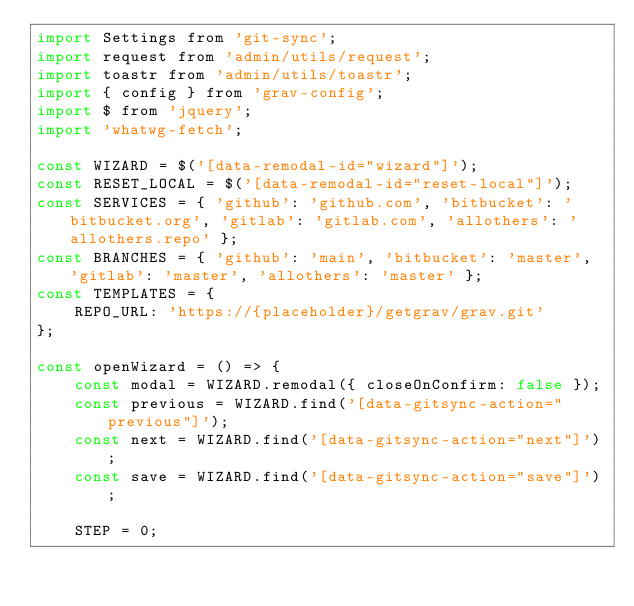Convert code to text. <code><loc_0><loc_0><loc_500><loc_500><_JavaScript_>import Settings from 'git-sync';
import request from 'admin/utils/request';
import toastr from 'admin/utils/toastr';
import { config } from 'grav-config';
import $ from 'jquery';
import 'whatwg-fetch';

const WIZARD = $('[data-remodal-id="wizard"]');
const RESET_LOCAL = $('[data-remodal-id="reset-local"]');
const SERVICES = { 'github': 'github.com', 'bitbucket': 'bitbucket.org', 'gitlab': 'gitlab.com', 'allothers': 'allothers.repo' };
const BRANCHES = { 'github': 'main', 'bitbucket': 'master', 'gitlab': 'master', 'allothers': 'master' };
const TEMPLATES = {
    REPO_URL: 'https://{placeholder}/getgrav/grav.git'
};

const openWizard = () => {
    const modal = WIZARD.remodal({ closeOnConfirm: false });
    const previous = WIZARD.find('[data-gitsync-action="previous"]');
    const next = WIZARD.find('[data-gitsync-action="next"]');
    const save = WIZARD.find('[data-gitsync-action="save"]');

    STEP = 0;
</code> 